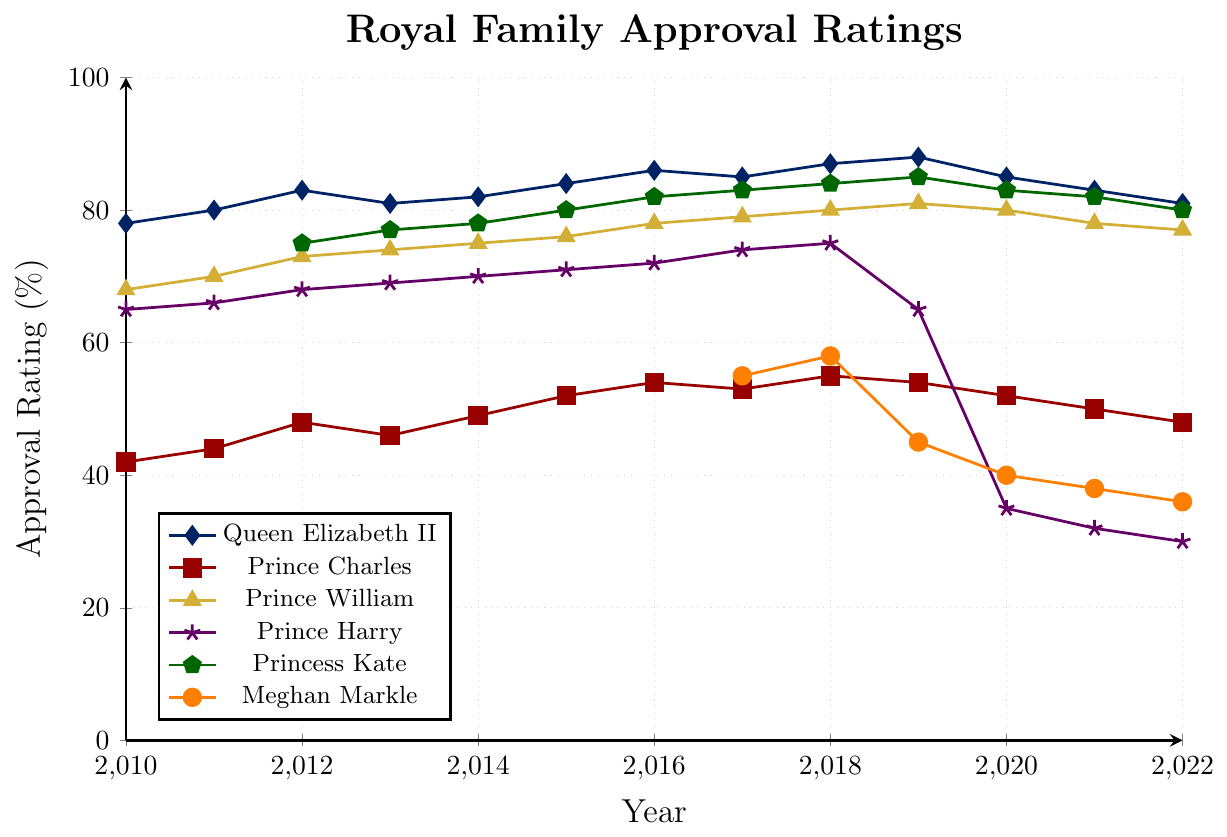What year did Queen Elizabeth II have the highest approval rating? The plot indicates that Queen Elizabeth II's highest approval rating occurred in 2019, which is reflected as the peak point
Answer: 2019 By how much did Prince Harry's approval rating decrease from 2018 to 2022? Prince Harry's approval rating in 2018 is 75% and in 2022 it is 30%. The difference is calculated as 75 - 30 = 45
Answer: 45% Which family member had the lowest approval rating in 2020? In the year 2020, comparing ratings from the plot, Meghan Markle had the lowest approval rating at 40%
Answer: Meghan Markle What is the average approval rating of Prince William from 2010 to 2022? Sum the ratings: 68 + 70 + 73 + 74 + 75 + 76 + 78 + 79 + 80 + 81 + 80 + 78 + 77 = 989. Divide by the number of years (13): 989 / 13 ≈ 76.08
Answer: 76.08 Between 2010 and 2022, which family member showed the most stable approval rating with the least fluctuation? By visually comparing the lines' trends and variations, Prince William's line shows the least fluctuation over the years
Answer: Prince William Who had the second-highest approval rating in 2016 and what was it? According to the plot, in 2016, Princess Kate had the second-highest approval rating at 82%, following Queen Elizabeth II
Answer: Princess Kate, 82% Compare Meghan Markle's approval rating change between 2017 and 2022 with Prince Harry's between the same years. Who had a greater decrease? Meghan Markle's rating changed from 55% in 2017 to 36% in 2022 (a decrease of 19%). Prince Harry's rating changed from 74% to 30% (a decrease of 44%). Prince Harry had a greater decrease in approval rating
Answer: Prince Harry What was Queen Elizabeth II's approval rating trend from 2018 to 2022? Observing the points from 2018 (87%) to 2022 (81%), there is a general decline in her approval rating
Answer: Decline Identify the year when Prince Charles's approval rating peaked and state the value. The highest point on the plot for Prince Charles is in 2018, with an approval rating of 55%
Answer: 2018, 55% Compare the approval ratings of Prince Harry and Princess Kate in 2019. Who had a higher rating and by how much? In 2019, Prince Harry had a 65% rating while Princess Kate had an 85% rating. The difference is 85 - 65 = 20
Answer: Princess Kate, by 20 